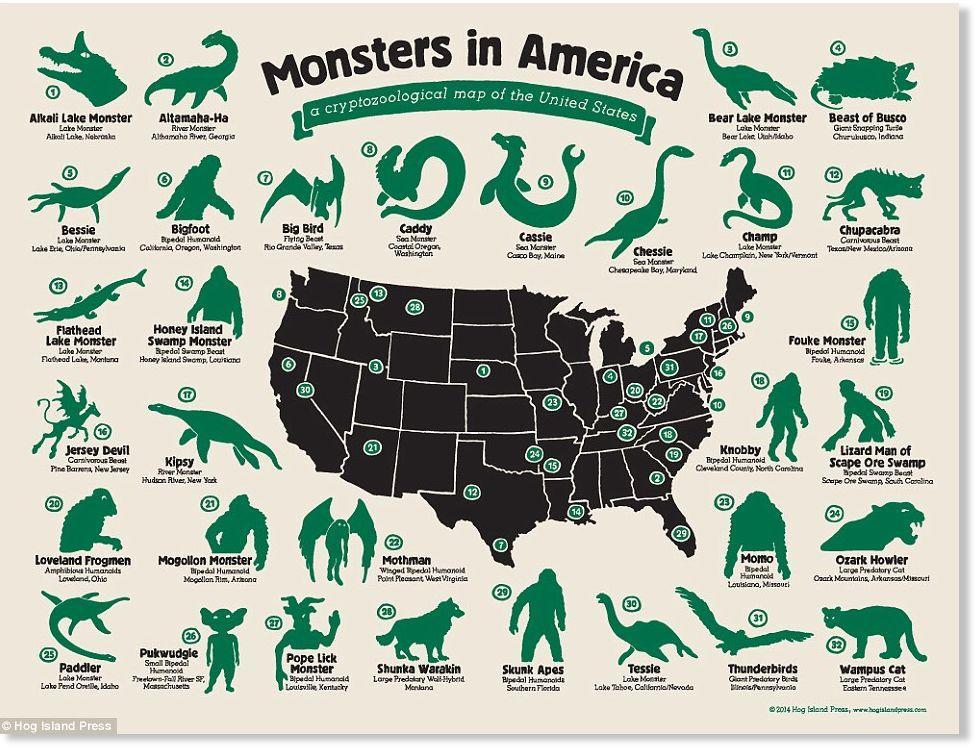What is the name of the 32nd Monster?
Answer the question with a short phrase. Wampus Cat Which is the Sea Monster found in Casco Bay, Maine? Cassie How many Monsters are listed in the info graphic? 32 Which monster is found in the southern most part of America? Big Bird What is the name of the monster which is found in Hudson River, New York? Kipsy Where the monster Skunk Apes is found? Southern Florida 